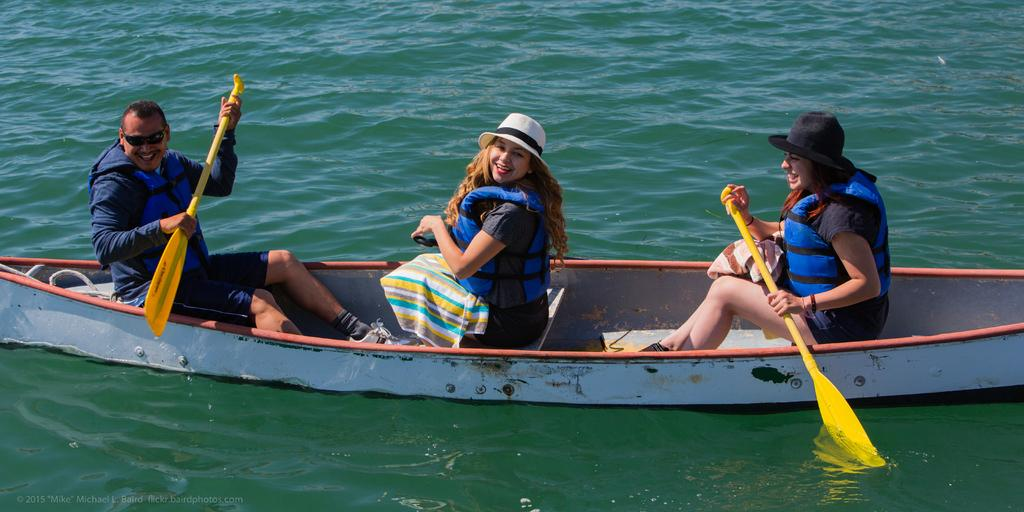How many people are in the image? There are three persons in the image. What are the persons doing in the image? The persons are sitting on a boat and smiling. What are the persons holding in the image? Two of the persons are holding yellow-colored oar sticks. Where is the boat located in the image? The boat is visible on a lake. What type of cabbage can be seen growing near the lake in the image? There is no cabbage present in the image; it only shows three persons sitting on a boat. What kind of machine is being used by the persons in the image? There is no machine visible in the image; the persons are holding yellow-colored oar sticks for rowing the boat. 